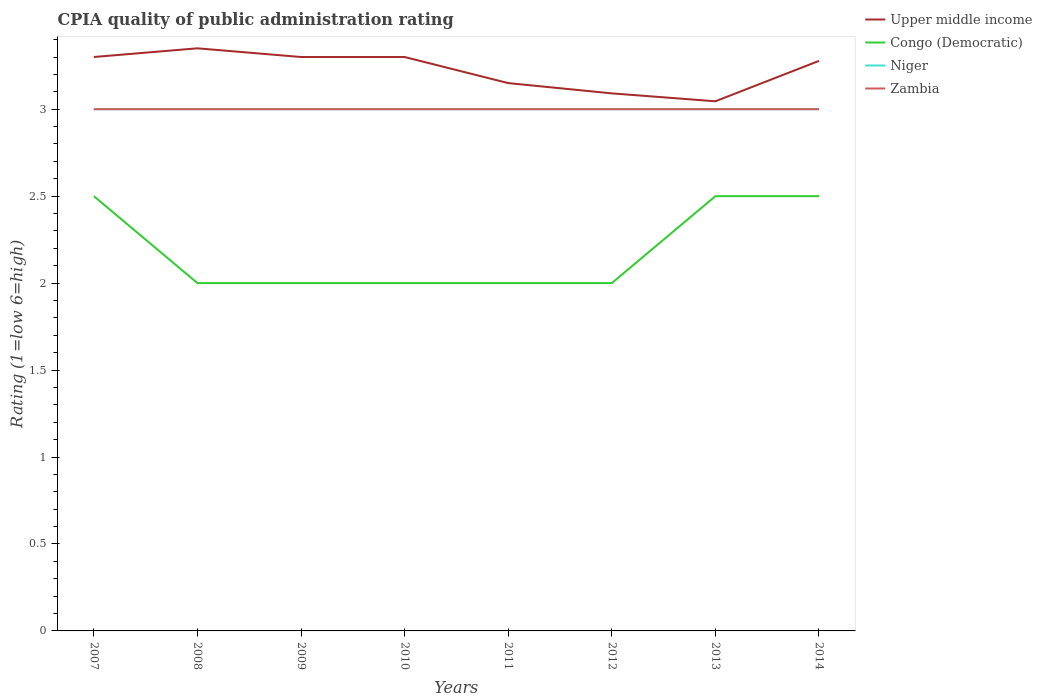How many different coloured lines are there?
Your answer should be very brief. 4. Across all years, what is the maximum CPIA rating in Zambia?
Your answer should be compact. 3. In which year was the CPIA rating in Upper middle income maximum?
Keep it short and to the point. 2013. What is the total CPIA rating in Niger in the graph?
Make the answer very short. 0. What is the difference between the highest and the second highest CPIA rating in Niger?
Ensure brevity in your answer.  0. What is the difference between the highest and the lowest CPIA rating in Congo (Democratic)?
Your answer should be compact. 3. How many years are there in the graph?
Your response must be concise. 8. What is the difference between two consecutive major ticks on the Y-axis?
Your answer should be very brief. 0.5. Does the graph contain any zero values?
Offer a terse response. No. Does the graph contain grids?
Offer a very short reply. No. Where does the legend appear in the graph?
Give a very brief answer. Top right. How are the legend labels stacked?
Give a very brief answer. Vertical. What is the title of the graph?
Your answer should be very brief. CPIA quality of public administration rating. Does "Madagascar" appear as one of the legend labels in the graph?
Your answer should be very brief. No. What is the label or title of the Y-axis?
Make the answer very short. Rating (1=low 6=high). What is the Rating (1=low 6=high) of Upper middle income in 2007?
Ensure brevity in your answer.  3.3. What is the Rating (1=low 6=high) in Upper middle income in 2008?
Offer a terse response. 3.35. What is the Rating (1=low 6=high) of Niger in 2009?
Make the answer very short. 3. What is the Rating (1=low 6=high) in Upper middle income in 2010?
Offer a very short reply. 3.3. What is the Rating (1=low 6=high) of Congo (Democratic) in 2010?
Provide a succinct answer. 2. What is the Rating (1=low 6=high) of Niger in 2010?
Keep it short and to the point. 3. What is the Rating (1=low 6=high) in Upper middle income in 2011?
Provide a short and direct response. 3.15. What is the Rating (1=low 6=high) in Niger in 2011?
Your answer should be compact. 3. What is the Rating (1=low 6=high) in Upper middle income in 2012?
Keep it short and to the point. 3.09. What is the Rating (1=low 6=high) of Congo (Democratic) in 2012?
Offer a very short reply. 2. What is the Rating (1=low 6=high) in Niger in 2012?
Your response must be concise. 3. What is the Rating (1=low 6=high) of Zambia in 2012?
Provide a short and direct response. 3. What is the Rating (1=low 6=high) of Upper middle income in 2013?
Your answer should be very brief. 3.05. What is the Rating (1=low 6=high) of Congo (Democratic) in 2013?
Ensure brevity in your answer.  2.5. What is the Rating (1=low 6=high) of Niger in 2013?
Give a very brief answer. 3. What is the Rating (1=low 6=high) in Zambia in 2013?
Make the answer very short. 3. What is the Rating (1=low 6=high) of Upper middle income in 2014?
Your answer should be compact. 3.28. What is the Rating (1=low 6=high) in Niger in 2014?
Offer a terse response. 3. What is the Rating (1=low 6=high) of Zambia in 2014?
Offer a terse response. 3. Across all years, what is the maximum Rating (1=low 6=high) in Upper middle income?
Provide a short and direct response. 3.35. Across all years, what is the maximum Rating (1=low 6=high) of Niger?
Provide a short and direct response. 3. Across all years, what is the minimum Rating (1=low 6=high) in Upper middle income?
Your answer should be very brief. 3.05. Across all years, what is the minimum Rating (1=low 6=high) in Niger?
Provide a succinct answer. 3. What is the total Rating (1=low 6=high) in Upper middle income in the graph?
Give a very brief answer. 25.81. What is the total Rating (1=low 6=high) in Niger in the graph?
Offer a terse response. 24. What is the total Rating (1=low 6=high) of Zambia in the graph?
Make the answer very short. 24. What is the difference between the Rating (1=low 6=high) of Upper middle income in 2007 and that in 2008?
Keep it short and to the point. -0.05. What is the difference between the Rating (1=low 6=high) in Zambia in 2007 and that in 2008?
Provide a short and direct response. 0. What is the difference between the Rating (1=low 6=high) of Upper middle income in 2007 and that in 2009?
Your response must be concise. 0. What is the difference between the Rating (1=low 6=high) of Congo (Democratic) in 2007 and that in 2009?
Give a very brief answer. 0.5. What is the difference between the Rating (1=low 6=high) in Upper middle income in 2007 and that in 2010?
Keep it short and to the point. 0. What is the difference between the Rating (1=low 6=high) in Congo (Democratic) in 2007 and that in 2011?
Ensure brevity in your answer.  0.5. What is the difference between the Rating (1=low 6=high) of Zambia in 2007 and that in 2011?
Keep it short and to the point. 0. What is the difference between the Rating (1=low 6=high) in Upper middle income in 2007 and that in 2012?
Provide a short and direct response. 0.21. What is the difference between the Rating (1=low 6=high) in Zambia in 2007 and that in 2012?
Offer a very short reply. 0. What is the difference between the Rating (1=low 6=high) of Upper middle income in 2007 and that in 2013?
Provide a succinct answer. 0.25. What is the difference between the Rating (1=low 6=high) in Congo (Democratic) in 2007 and that in 2013?
Keep it short and to the point. 0. What is the difference between the Rating (1=low 6=high) of Zambia in 2007 and that in 2013?
Your response must be concise. 0. What is the difference between the Rating (1=low 6=high) in Upper middle income in 2007 and that in 2014?
Make the answer very short. 0.02. What is the difference between the Rating (1=low 6=high) of Congo (Democratic) in 2007 and that in 2014?
Offer a very short reply. 0. What is the difference between the Rating (1=low 6=high) in Zambia in 2007 and that in 2014?
Ensure brevity in your answer.  0. What is the difference between the Rating (1=low 6=high) of Upper middle income in 2008 and that in 2009?
Keep it short and to the point. 0.05. What is the difference between the Rating (1=low 6=high) in Niger in 2008 and that in 2009?
Your response must be concise. 0. What is the difference between the Rating (1=low 6=high) of Zambia in 2008 and that in 2009?
Make the answer very short. 0. What is the difference between the Rating (1=low 6=high) in Upper middle income in 2008 and that in 2010?
Your answer should be very brief. 0.05. What is the difference between the Rating (1=low 6=high) of Niger in 2008 and that in 2010?
Provide a succinct answer. 0. What is the difference between the Rating (1=low 6=high) in Zambia in 2008 and that in 2010?
Ensure brevity in your answer.  0. What is the difference between the Rating (1=low 6=high) of Zambia in 2008 and that in 2011?
Provide a succinct answer. 0. What is the difference between the Rating (1=low 6=high) of Upper middle income in 2008 and that in 2012?
Offer a terse response. 0.26. What is the difference between the Rating (1=low 6=high) of Niger in 2008 and that in 2012?
Provide a succinct answer. 0. What is the difference between the Rating (1=low 6=high) in Upper middle income in 2008 and that in 2013?
Provide a succinct answer. 0.3. What is the difference between the Rating (1=low 6=high) in Congo (Democratic) in 2008 and that in 2013?
Your answer should be very brief. -0.5. What is the difference between the Rating (1=low 6=high) in Zambia in 2008 and that in 2013?
Your answer should be compact. 0. What is the difference between the Rating (1=low 6=high) of Upper middle income in 2008 and that in 2014?
Provide a short and direct response. 0.07. What is the difference between the Rating (1=low 6=high) of Niger in 2008 and that in 2014?
Ensure brevity in your answer.  0. What is the difference between the Rating (1=low 6=high) in Zambia in 2008 and that in 2014?
Provide a succinct answer. 0. What is the difference between the Rating (1=low 6=high) in Congo (Democratic) in 2009 and that in 2010?
Your answer should be very brief. 0. What is the difference between the Rating (1=low 6=high) in Upper middle income in 2009 and that in 2011?
Provide a short and direct response. 0.15. What is the difference between the Rating (1=low 6=high) in Congo (Democratic) in 2009 and that in 2011?
Ensure brevity in your answer.  0. What is the difference between the Rating (1=low 6=high) in Zambia in 2009 and that in 2011?
Your answer should be compact. 0. What is the difference between the Rating (1=low 6=high) of Upper middle income in 2009 and that in 2012?
Ensure brevity in your answer.  0.21. What is the difference between the Rating (1=low 6=high) of Upper middle income in 2009 and that in 2013?
Offer a very short reply. 0.25. What is the difference between the Rating (1=low 6=high) in Zambia in 2009 and that in 2013?
Provide a short and direct response. 0. What is the difference between the Rating (1=low 6=high) of Upper middle income in 2009 and that in 2014?
Your response must be concise. 0.02. What is the difference between the Rating (1=low 6=high) of Niger in 2009 and that in 2014?
Offer a terse response. 0. What is the difference between the Rating (1=low 6=high) of Zambia in 2009 and that in 2014?
Your answer should be compact. 0. What is the difference between the Rating (1=low 6=high) in Upper middle income in 2010 and that in 2011?
Give a very brief answer. 0.15. What is the difference between the Rating (1=low 6=high) in Congo (Democratic) in 2010 and that in 2011?
Offer a terse response. 0. What is the difference between the Rating (1=low 6=high) in Niger in 2010 and that in 2011?
Your response must be concise. 0. What is the difference between the Rating (1=low 6=high) of Upper middle income in 2010 and that in 2012?
Your answer should be compact. 0.21. What is the difference between the Rating (1=low 6=high) of Congo (Democratic) in 2010 and that in 2012?
Keep it short and to the point. 0. What is the difference between the Rating (1=low 6=high) in Zambia in 2010 and that in 2012?
Give a very brief answer. 0. What is the difference between the Rating (1=low 6=high) of Upper middle income in 2010 and that in 2013?
Give a very brief answer. 0.25. What is the difference between the Rating (1=low 6=high) of Niger in 2010 and that in 2013?
Provide a succinct answer. 0. What is the difference between the Rating (1=low 6=high) of Upper middle income in 2010 and that in 2014?
Your answer should be compact. 0.02. What is the difference between the Rating (1=low 6=high) in Congo (Democratic) in 2010 and that in 2014?
Your answer should be compact. -0.5. What is the difference between the Rating (1=low 6=high) in Upper middle income in 2011 and that in 2012?
Offer a very short reply. 0.06. What is the difference between the Rating (1=low 6=high) in Congo (Democratic) in 2011 and that in 2012?
Your answer should be compact. 0. What is the difference between the Rating (1=low 6=high) in Upper middle income in 2011 and that in 2013?
Your answer should be compact. 0.1. What is the difference between the Rating (1=low 6=high) in Congo (Democratic) in 2011 and that in 2013?
Offer a terse response. -0.5. What is the difference between the Rating (1=low 6=high) of Zambia in 2011 and that in 2013?
Your response must be concise. 0. What is the difference between the Rating (1=low 6=high) of Upper middle income in 2011 and that in 2014?
Give a very brief answer. -0.13. What is the difference between the Rating (1=low 6=high) of Niger in 2011 and that in 2014?
Provide a short and direct response. 0. What is the difference between the Rating (1=low 6=high) in Upper middle income in 2012 and that in 2013?
Offer a terse response. 0.05. What is the difference between the Rating (1=low 6=high) of Congo (Democratic) in 2012 and that in 2013?
Keep it short and to the point. -0.5. What is the difference between the Rating (1=low 6=high) in Niger in 2012 and that in 2013?
Your answer should be very brief. 0. What is the difference between the Rating (1=low 6=high) of Zambia in 2012 and that in 2013?
Your answer should be compact. 0. What is the difference between the Rating (1=low 6=high) of Upper middle income in 2012 and that in 2014?
Offer a very short reply. -0.19. What is the difference between the Rating (1=low 6=high) of Congo (Democratic) in 2012 and that in 2014?
Offer a very short reply. -0.5. What is the difference between the Rating (1=low 6=high) of Upper middle income in 2013 and that in 2014?
Provide a succinct answer. -0.23. What is the difference between the Rating (1=low 6=high) in Niger in 2013 and that in 2014?
Keep it short and to the point. 0. What is the difference between the Rating (1=low 6=high) in Zambia in 2013 and that in 2014?
Your answer should be very brief. 0. What is the difference between the Rating (1=low 6=high) of Upper middle income in 2007 and the Rating (1=low 6=high) of Niger in 2008?
Your answer should be very brief. 0.3. What is the difference between the Rating (1=low 6=high) in Upper middle income in 2007 and the Rating (1=low 6=high) in Zambia in 2008?
Your response must be concise. 0.3. What is the difference between the Rating (1=low 6=high) of Congo (Democratic) in 2007 and the Rating (1=low 6=high) of Niger in 2008?
Keep it short and to the point. -0.5. What is the difference between the Rating (1=low 6=high) of Upper middle income in 2007 and the Rating (1=low 6=high) of Congo (Democratic) in 2009?
Provide a short and direct response. 1.3. What is the difference between the Rating (1=low 6=high) in Upper middle income in 2007 and the Rating (1=low 6=high) in Zambia in 2009?
Your response must be concise. 0.3. What is the difference between the Rating (1=low 6=high) in Congo (Democratic) in 2007 and the Rating (1=low 6=high) in Niger in 2009?
Give a very brief answer. -0.5. What is the difference between the Rating (1=low 6=high) in Congo (Democratic) in 2007 and the Rating (1=low 6=high) in Zambia in 2009?
Your answer should be compact. -0.5. What is the difference between the Rating (1=low 6=high) in Upper middle income in 2007 and the Rating (1=low 6=high) in Congo (Democratic) in 2010?
Make the answer very short. 1.3. What is the difference between the Rating (1=low 6=high) in Upper middle income in 2007 and the Rating (1=low 6=high) in Zambia in 2011?
Your response must be concise. 0.3. What is the difference between the Rating (1=low 6=high) of Congo (Democratic) in 2007 and the Rating (1=low 6=high) of Niger in 2011?
Offer a very short reply. -0.5. What is the difference between the Rating (1=low 6=high) in Congo (Democratic) in 2007 and the Rating (1=low 6=high) in Zambia in 2011?
Keep it short and to the point. -0.5. What is the difference between the Rating (1=low 6=high) in Upper middle income in 2007 and the Rating (1=low 6=high) in Niger in 2012?
Your response must be concise. 0.3. What is the difference between the Rating (1=low 6=high) in Niger in 2007 and the Rating (1=low 6=high) in Zambia in 2012?
Ensure brevity in your answer.  0. What is the difference between the Rating (1=low 6=high) of Congo (Democratic) in 2007 and the Rating (1=low 6=high) of Zambia in 2013?
Keep it short and to the point. -0.5. What is the difference between the Rating (1=low 6=high) in Niger in 2007 and the Rating (1=low 6=high) in Zambia in 2013?
Give a very brief answer. 0. What is the difference between the Rating (1=low 6=high) in Upper middle income in 2007 and the Rating (1=low 6=high) in Congo (Democratic) in 2014?
Your answer should be very brief. 0.8. What is the difference between the Rating (1=low 6=high) in Upper middle income in 2007 and the Rating (1=low 6=high) in Zambia in 2014?
Give a very brief answer. 0.3. What is the difference between the Rating (1=low 6=high) in Congo (Democratic) in 2007 and the Rating (1=low 6=high) in Niger in 2014?
Keep it short and to the point. -0.5. What is the difference between the Rating (1=low 6=high) of Niger in 2007 and the Rating (1=low 6=high) of Zambia in 2014?
Provide a succinct answer. 0. What is the difference between the Rating (1=low 6=high) in Upper middle income in 2008 and the Rating (1=low 6=high) in Congo (Democratic) in 2009?
Keep it short and to the point. 1.35. What is the difference between the Rating (1=low 6=high) in Niger in 2008 and the Rating (1=low 6=high) in Zambia in 2009?
Give a very brief answer. 0. What is the difference between the Rating (1=low 6=high) in Upper middle income in 2008 and the Rating (1=low 6=high) in Congo (Democratic) in 2010?
Your answer should be compact. 1.35. What is the difference between the Rating (1=low 6=high) in Upper middle income in 2008 and the Rating (1=low 6=high) in Niger in 2010?
Give a very brief answer. 0.35. What is the difference between the Rating (1=low 6=high) in Upper middle income in 2008 and the Rating (1=low 6=high) in Zambia in 2010?
Keep it short and to the point. 0.35. What is the difference between the Rating (1=low 6=high) in Congo (Democratic) in 2008 and the Rating (1=low 6=high) in Zambia in 2010?
Offer a terse response. -1. What is the difference between the Rating (1=low 6=high) of Upper middle income in 2008 and the Rating (1=low 6=high) of Congo (Democratic) in 2011?
Offer a very short reply. 1.35. What is the difference between the Rating (1=low 6=high) of Upper middle income in 2008 and the Rating (1=low 6=high) of Niger in 2011?
Keep it short and to the point. 0.35. What is the difference between the Rating (1=low 6=high) of Upper middle income in 2008 and the Rating (1=low 6=high) of Zambia in 2011?
Your answer should be compact. 0.35. What is the difference between the Rating (1=low 6=high) of Upper middle income in 2008 and the Rating (1=low 6=high) of Congo (Democratic) in 2012?
Provide a succinct answer. 1.35. What is the difference between the Rating (1=low 6=high) of Upper middle income in 2008 and the Rating (1=low 6=high) of Niger in 2012?
Offer a terse response. 0.35. What is the difference between the Rating (1=low 6=high) of Upper middle income in 2008 and the Rating (1=low 6=high) of Zambia in 2012?
Give a very brief answer. 0.35. What is the difference between the Rating (1=low 6=high) in Congo (Democratic) in 2008 and the Rating (1=low 6=high) in Niger in 2012?
Your response must be concise. -1. What is the difference between the Rating (1=low 6=high) of Congo (Democratic) in 2008 and the Rating (1=low 6=high) of Zambia in 2012?
Ensure brevity in your answer.  -1. What is the difference between the Rating (1=low 6=high) of Upper middle income in 2008 and the Rating (1=low 6=high) of Niger in 2013?
Offer a very short reply. 0.35. What is the difference between the Rating (1=low 6=high) in Congo (Democratic) in 2008 and the Rating (1=low 6=high) in Niger in 2013?
Your response must be concise. -1. What is the difference between the Rating (1=low 6=high) in Congo (Democratic) in 2008 and the Rating (1=low 6=high) in Zambia in 2013?
Keep it short and to the point. -1. What is the difference between the Rating (1=low 6=high) of Upper middle income in 2008 and the Rating (1=low 6=high) of Congo (Democratic) in 2014?
Your answer should be compact. 0.85. What is the difference between the Rating (1=low 6=high) of Upper middle income in 2008 and the Rating (1=low 6=high) of Niger in 2014?
Keep it short and to the point. 0.35. What is the difference between the Rating (1=low 6=high) of Upper middle income in 2009 and the Rating (1=low 6=high) of Congo (Democratic) in 2010?
Offer a very short reply. 1.3. What is the difference between the Rating (1=low 6=high) of Congo (Democratic) in 2009 and the Rating (1=low 6=high) of Niger in 2010?
Make the answer very short. -1. What is the difference between the Rating (1=low 6=high) in Congo (Democratic) in 2009 and the Rating (1=low 6=high) in Zambia in 2010?
Provide a short and direct response. -1. What is the difference between the Rating (1=low 6=high) in Niger in 2009 and the Rating (1=low 6=high) in Zambia in 2010?
Ensure brevity in your answer.  0. What is the difference between the Rating (1=low 6=high) of Niger in 2009 and the Rating (1=low 6=high) of Zambia in 2011?
Make the answer very short. 0. What is the difference between the Rating (1=low 6=high) in Upper middle income in 2009 and the Rating (1=low 6=high) in Congo (Democratic) in 2012?
Your answer should be very brief. 1.3. What is the difference between the Rating (1=low 6=high) in Upper middle income in 2009 and the Rating (1=low 6=high) in Niger in 2012?
Your answer should be very brief. 0.3. What is the difference between the Rating (1=low 6=high) of Upper middle income in 2009 and the Rating (1=low 6=high) of Zambia in 2012?
Make the answer very short. 0.3. What is the difference between the Rating (1=low 6=high) of Congo (Democratic) in 2009 and the Rating (1=low 6=high) of Zambia in 2012?
Make the answer very short. -1. What is the difference between the Rating (1=low 6=high) in Niger in 2009 and the Rating (1=low 6=high) in Zambia in 2012?
Provide a short and direct response. 0. What is the difference between the Rating (1=low 6=high) of Upper middle income in 2009 and the Rating (1=low 6=high) of Zambia in 2013?
Your answer should be very brief. 0.3. What is the difference between the Rating (1=low 6=high) of Congo (Democratic) in 2009 and the Rating (1=low 6=high) of Niger in 2013?
Provide a succinct answer. -1. What is the difference between the Rating (1=low 6=high) of Congo (Democratic) in 2009 and the Rating (1=low 6=high) of Zambia in 2013?
Your answer should be very brief. -1. What is the difference between the Rating (1=low 6=high) in Niger in 2009 and the Rating (1=low 6=high) in Zambia in 2013?
Ensure brevity in your answer.  0. What is the difference between the Rating (1=low 6=high) in Upper middle income in 2009 and the Rating (1=low 6=high) in Congo (Democratic) in 2014?
Provide a succinct answer. 0.8. What is the difference between the Rating (1=low 6=high) in Upper middle income in 2009 and the Rating (1=low 6=high) in Niger in 2014?
Your answer should be compact. 0.3. What is the difference between the Rating (1=low 6=high) of Upper middle income in 2009 and the Rating (1=low 6=high) of Zambia in 2014?
Your response must be concise. 0.3. What is the difference between the Rating (1=low 6=high) in Niger in 2009 and the Rating (1=low 6=high) in Zambia in 2014?
Make the answer very short. 0. What is the difference between the Rating (1=low 6=high) in Upper middle income in 2010 and the Rating (1=low 6=high) in Congo (Democratic) in 2011?
Your response must be concise. 1.3. What is the difference between the Rating (1=low 6=high) of Upper middle income in 2010 and the Rating (1=low 6=high) of Niger in 2011?
Provide a short and direct response. 0.3. What is the difference between the Rating (1=low 6=high) of Upper middle income in 2010 and the Rating (1=low 6=high) of Zambia in 2011?
Keep it short and to the point. 0.3. What is the difference between the Rating (1=low 6=high) in Congo (Democratic) in 2010 and the Rating (1=low 6=high) in Zambia in 2011?
Ensure brevity in your answer.  -1. What is the difference between the Rating (1=low 6=high) of Niger in 2010 and the Rating (1=low 6=high) of Zambia in 2011?
Make the answer very short. 0. What is the difference between the Rating (1=low 6=high) of Upper middle income in 2010 and the Rating (1=low 6=high) of Congo (Democratic) in 2012?
Your answer should be very brief. 1.3. What is the difference between the Rating (1=low 6=high) of Upper middle income in 2010 and the Rating (1=low 6=high) of Niger in 2012?
Provide a short and direct response. 0.3. What is the difference between the Rating (1=low 6=high) in Upper middle income in 2010 and the Rating (1=low 6=high) in Zambia in 2012?
Your answer should be very brief. 0.3. What is the difference between the Rating (1=low 6=high) of Niger in 2010 and the Rating (1=low 6=high) of Zambia in 2012?
Make the answer very short. 0. What is the difference between the Rating (1=low 6=high) of Upper middle income in 2010 and the Rating (1=low 6=high) of Zambia in 2013?
Offer a terse response. 0.3. What is the difference between the Rating (1=low 6=high) in Congo (Democratic) in 2010 and the Rating (1=low 6=high) in Niger in 2013?
Your answer should be very brief. -1. What is the difference between the Rating (1=low 6=high) in Congo (Democratic) in 2010 and the Rating (1=low 6=high) in Zambia in 2013?
Keep it short and to the point. -1. What is the difference between the Rating (1=low 6=high) in Upper middle income in 2010 and the Rating (1=low 6=high) in Niger in 2014?
Keep it short and to the point. 0.3. What is the difference between the Rating (1=low 6=high) of Congo (Democratic) in 2010 and the Rating (1=low 6=high) of Zambia in 2014?
Keep it short and to the point. -1. What is the difference between the Rating (1=low 6=high) of Niger in 2010 and the Rating (1=low 6=high) of Zambia in 2014?
Keep it short and to the point. 0. What is the difference between the Rating (1=low 6=high) in Upper middle income in 2011 and the Rating (1=low 6=high) in Congo (Democratic) in 2012?
Keep it short and to the point. 1.15. What is the difference between the Rating (1=low 6=high) of Upper middle income in 2011 and the Rating (1=low 6=high) of Niger in 2012?
Make the answer very short. 0.15. What is the difference between the Rating (1=low 6=high) in Upper middle income in 2011 and the Rating (1=low 6=high) in Zambia in 2012?
Provide a succinct answer. 0.15. What is the difference between the Rating (1=low 6=high) in Congo (Democratic) in 2011 and the Rating (1=low 6=high) in Niger in 2012?
Ensure brevity in your answer.  -1. What is the difference between the Rating (1=low 6=high) in Upper middle income in 2011 and the Rating (1=low 6=high) in Congo (Democratic) in 2013?
Provide a succinct answer. 0.65. What is the difference between the Rating (1=low 6=high) of Upper middle income in 2011 and the Rating (1=low 6=high) of Niger in 2013?
Ensure brevity in your answer.  0.15. What is the difference between the Rating (1=low 6=high) of Congo (Democratic) in 2011 and the Rating (1=low 6=high) of Niger in 2013?
Your answer should be compact. -1. What is the difference between the Rating (1=low 6=high) of Niger in 2011 and the Rating (1=low 6=high) of Zambia in 2013?
Your answer should be very brief. 0. What is the difference between the Rating (1=low 6=high) in Upper middle income in 2011 and the Rating (1=low 6=high) in Congo (Democratic) in 2014?
Ensure brevity in your answer.  0.65. What is the difference between the Rating (1=low 6=high) of Upper middle income in 2011 and the Rating (1=low 6=high) of Niger in 2014?
Keep it short and to the point. 0.15. What is the difference between the Rating (1=low 6=high) of Upper middle income in 2011 and the Rating (1=low 6=high) of Zambia in 2014?
Offer a terse response. 0.15. What is the difference between the Rating (1=low 6=high) in Congo (Democratic) in 2011 and the Rating (1=low 6=high) in Zambia in 2014?
Your response must be concise. -1. What is the difference between the Rating (1=low 6=high) in Upper middle income in 2012 and the Rating (1=low 6=high) in Congo (Democratic) in 2013?
Your response must be concise. 0.59. What is the difference between the Rating (1=low 6=high) in Upper middle income in 2012 and the Rating (1=low 6=high) in Niger in 2013?
Make the answer very short. 0.09. What is the difference between the Rating (1=low 6=high) of Upper middle income in 2012 and the Rating (1=low 6=high) of Zambia in 2013?
Provide a short and direct response. 0.09. What is the difference between the Rating (1=low 6=high) in Congo (Democratic) in 2012 and the Rating (1=low 6=high) in Niger in 2013?
Provide a succinct answer. -1. What is the difference between the Rating (1=low 6=high) in Congo (Democratic) in 2012 and the Rating (1=low 6=high) in Zambia in 2013?
Give a very brief answer. -1. What is the difference between the Rating (1=low 6=high) in Niger in 2012 and the Rating (1=low 6=high) in Zambia in 2013?
Give a very brief answer. 0. What is the difference between the Rating (1=low 6=high) in Upper middle income in 2012 and the Rating (1=low 6=high) in Congo (Democratic) in 2014?
Give a very brief answer. 0.59. What is the difference between the Rating (1=low 6=high) of Upper middle income in 2012 and the Rating (1=low 6=high) of Niger in 2014?
Ensure brevity in your answer.  0.09. What is the difference between the Rating (1=low 6=high) of Upper middle income in 2012 and the Rating (1=low 6=high) of Zambia in 2014?
Offer a terse response. 0.09. What is the difference between the Rating (1=low 6=high) of Congo (Democratic) in 2012 and the Rating (1=low 6=high) of Niger in 2014?
Provide a succinct answer. -1. What is the difference between the Rating (1=low 6=high) of Congo (Democratic) in 2012 and the Rating (1=low 6=high) of Zambia in 2014?
Your response must be concise. -1. What is the difference between the Rating (1=low 6=high) of Upper middle income in 2013 and the Rating (1=low 6=high) of Congo (Democratic) in 2014?
Provide a short and direct response. 0.55. What is the difference between the Rating (1=low 6=high) in Upper middle income in 2013 and the Rating (1=low 6=high) in Niger in 2014?
Offer a very short reply. 0.05. What is the difference between the Rating (1=low 6=high) in Upper middle income in 2013 and the Rating (1=low 6=high) in Zambia in 2014?
Your response must be concise. 0.05. What is the difference between the Rating (1=low 6=high) in Congo (Democratic) in 2013 and the Rating (1=low 6=high) in Niger in 2014?
Offer a very short reply. -0.5. What is the difference between the Rating (1=low 6=high) of Niger in 2013 and the Rating (1=low 6=high) of Zambia in 2014?
Make the answer very short. 0. What is the average Rating (1=low 6=high) in Upper middle income per year?
Make the answer very short. 3.23. What is the average Rating (1=low 6=high) in Congo (Democratic) per year?
Your answer should be very brief. 2.19. What is the average Rating (1=low 6=high) of Niger per year?
Your response must be concise. 3. What is the average Rating (1=low 6=high) of Zambia per year?
Offer a very short reply. 3. In the year 2007, what is the difference between the Rating (1=low 6=high) in Upper middle income and Rating (1=low 6=high) in Congo (Democratic)?
Your response must be concise. 0.8. In the year 2007, what is the difference between the Rating (1=low 6=high) of Upper middle income and Rating (1=low 6=high) of Niger?
Provide a short and direct response. 0.3. In the year 2007, what is the difference between the Rating (1=low 6=high) of Upper middle income and Rating (1=low 6=high) of Zambia?
Your answer should be very brief. 0.3. In the year 2007, what is the difference between the Rating (1=low 6=high) in Niger and Rating (1=low 6=high) in Zambia?
Offer a very short reply. 0. In the year 2008, what is the difference between the Rating (1=low 6=high) in Upper middle income and Rating (1=low 6=high) in Congo (Democratic)?
Your answer should be very brief. 1.35. In the year 2008, what is the difference between the Rating (1=low 6=high) in Congo (Democratic) and Rating (1=low 6=high) in Zambia?
Give a very brief answer. -1. In the year 2009, what is the difference between the Rating (1=low 6=high) in Upper middle income and Rating (1=low 6=high) in Niger?
Your answer should be very brief. 0.3. In the year 2009, what is the difference between the Rating (1=low 6=high) in Congo (Democratic) and Rating (1=low 6=high) in Niger?
Offer a very short reply. -1. In the year 2009, what is the difference between the Rating (1=low 6=high) in Congo (Democratic) and Rating (1=low 6=high) in Zambia?
Provide a succinct answer. -1. In the year 2010, what is the difference between the Rating (1=low 6=high) in Upper middle income and Rating (1=low 6=high) in Congo (Democratic)?
Keep it short and to the point. 1.3. In the year 2010, what is the difference between the Rating (1=low 6=high) in Upper middle income and Rating (1=low 6=high) in Zambia?
Your answer should be compact. 0.3. In the year 2010, what is the difference between the Rating (1=low 6=high) of Congo (Democratic) and Rating (1=low 6=high) of Niger?
Your answer should be compact. -1. In the year 2010, what is the difference between the Rating (1=low 6=high) of Congo (Democratic) and Rating (1=low 6=high) of Zambia?
Make the answer very short. -1. In the year 2010, what is the difference between the Rating (1=low 6=high) of Niger and Rating (1=low 6=high) of Zambia?
Provide a succinct answer. 0. In the year 2011, what is the difference between the Rating (1=low 6=high) of Upper middle income and Rating (1=low 6=high) of Congo (Democratic)?
Provide a short and direct response. 1.15. In the year 2011, what is the difference between the Rating (1=low 6=high) in Congo (Democratic) and Rating (1=low 6=high) in Zambia?
Make the answer very short. -1. In the year 2012, what is the difference between the Rating (1=low 6=high) in Upper middle income and Rating (1=low 6=high) in Congo (Democratic)?
Offer a very short reply. 1.09. In the year 2012, what is the difference between the Rating (1=low 6=high) in Upper middle income and Rating (1=low 6=high) in Niger?
Keep it short and to the point. 0.09. In the year 2012, what is the difference between the Rating (1=low 6=high) in Upper middle income and Rating (1=low 6=high) in Zambia?
Provide a short and direct response. 0.09. In the year 2012, what is the difference between the Rating (1=low 6=high) in Congo (Democratic) and Rating (1=low 6=high) in Zambia?
Your response must be concise. -1. In the year 2013, what is the difference between the Rating (1=low 6=high) of Upper middle income and Rating (1=low 6=high) of Congo (Democratic)?
Your response must be concise. 0.55. In the year 2013, what is the difference between the Rating (1=low 6=high) of Upper middle income and Rating (1=low 6=high) of Niger?
Your answer should be very brief. 0.05. In the year 2013, what is the difference between the Rating (1=low 6=high) in Upper middle income and Rating (1=low 6=high) in Zambia?
Your answer should be very brief. 0.05. In the year 2013, what is the difference between the Rating (1=low 6=high) in Congo (Democratic) and Rating (1=low 6=high) in Niger?
Your answer should be very brief. -0.5. In the year 2013, what is the difference between the Rating (1=low 6=high) in Congo (Democratic) and Rating (1=low 6=high) in Zambia?
Provide a succinct answer. -0.5. In the year 2013, what is the difference between the Rating (1=low 6=high) of Niger and Rating (1=low 6=high) of Zambia?
Keep it short and to the point. 0. In the year 2014, what is the difference between the Rating (1=low 6=high) in Upper middle income and Rating (1=low 6=high) in Congo (Democratic)?
Give a very brief answer. 0.78. In the year 2014, what is the difference between the Rating (1=low 6=high) in Upper middle income and Rating (1=low 6=high) in Niger?
Your response must be concise. 0.28. In the year 2014, what is the difference between the Rating (1=low 6=high) of Upper middle income and Rating (1=low 6=high) of Zambia?
Offer a very short reply. 0.28. In the year 2014, what is the difference between the Rating (1=low 6=high) in Congo (Democratic) and Rating (1=low 6=high) in Niger?
Your response must be concise. -0.5. In the year 2014, what is the difference between the Rating (1=low 6=high) of Congo (Democratic) and Rating (1=low 6=high) of Zambia?
Offer a very short reply. -0.5. In the year 2014, what is the difference between the Rating (1=low 6=high) of Niger and Rating (1=low 6=high) of Zambia?
Your answer should be very brief. 0. What is the ratio of the Rating (1=low 6=high) in Upper middle income in 2007 to that in 2008?
Offer a terse response. 0.99. What is the ratio of the Rating (1=low 6=high) in Congo (Democratic) in 2007 to that in 2008?
Offer a very short reply. 1.25. What is the ratio of the Rating (1=low 6=high) in Zambia in 2007 to that in 2008?
Offer a very short reply. 1. What is the ratio of the Rating (1=low 6=high) in Zambia in 2007 to that in 2009?
Your answer should be compact. 1. What is the ratio of the Rating (1=low 6=high) of Congo (Democratic) in 2007 to that in 2010?
Give a very brief answer. 1.25. What is the ratio of the Rating (1=low 6=high) in Upper middle income in 2007 to that in 2011?
Provide a short and direct response. 1.05. What is the ratio of the Rating (1=low 6=high) of Congo (Democratic) in 2007 to that in 2011?
Your answer should be compact. 1.25. What is the ratio of the Rating (1=low 6=high) in Niger in 2007 to that in 2011?
Make the answer very short. 1. What is the ratio of the Rating (1=low 6=high) of Zambia in 2007 to that in 2011?
Offer a terse response. 1. What is the ratio of the Rating (1=low 6=high) in Upper middle income in 2007 to that in 2012?
Ensure brevity in your answer.  1.07. What is the ratio of the Rating (1=low 6=high) in Congo (Democratic) in 2007 to that in 2012?
Your answer should be very brief. 1.25. What is the ratio of the Rating (1=low 6=high) in Zambia in 2007 to that in 2012?
Give a very brief answer. 1. What is the ratio of the Rating (1=low 6=high) in Upper middle income in 2007 to that in 2013?
Provide a succinct answer. 1.08. What is the ratio of the Rating (1=low 6=high) of Congo (Democratic) in 2007 to that in 2013?
Offer a very short reply. 1. What is the ratio of the Rating (1=low 6=high) of Niger in 2007 to that in 2013?
Offer a terse response. 1. What is the ratio of the Rating (1=low 6=high) in Zambia in 2007 to that in 2013?
Provide a succinct answer. 1. What is the ratio of the Rating (1=low 6=high) of Upper middle income in 2007 to that in 2014?
Keep it short and to the point. 1.01. What is the ratio of the Rating (1=low 6=high) of Niger in 2007 to that in 2014?
Provide a succinct answer. 1. What is the ratio of the Rating (1=low 6=high) in Upper middle income in 2008 to that in 2009?
Keep it short and to the point. 1.02. What is the ratio of the Rating (1=low 6=high) in Congo (Democratic) in 2008 to that in 2009?
Provide a short and direct response. 1. What is the ratio of the Rating (1=low 6=high) in Upper middle income in 2008 to that in 2010?
Keep it short and to the point. 1.02. What is the ratio of the Rating (1=low 6=high) of Congo (Democratic) in 2008 to that in 2010?
Keep it short and to the point. 1. What is the ratio of the Rating (1=low 6=high) in Upper middle income in 2008 to that in 2011?
Give a very brief answer. 1.06. What is the ratio of the Rating (1=low 6=high) in Niger in 2008 to that in 2011?
Give a very brief answer. 1. What is the ratio of the Rating (1=low 6=high) in Zambia in 2008 to that in 2011?
Offer a terse response. 1. What is the ratio of the Rating (1=low 6=high) in Upper middle income in 2008 to that in 2012?
Keep it short and to the point. 1.08. What is the ratio of the Rating (1=low 6=high) in Congo (Democratic) in 2008 to that in 2012?
Provide a short and direct response. 1. What is the ratio of the Rating (1=low 6=high) in Upper middle income in 2008 to that in 2013?
Keep it short and to the point. 1.1. What is the ratio of the Rating (1=low 6=high) of Congo (Democratic) in 2008 to that in 2013?
Provide a succinct answer. 0.8. What is the ratio of the Rating (1=low 6=high) of Niger in 2008 to that in 2013?
Your answer should be compact. 1. What is the ratio of the Rating (1=low 6=high) of Congo (Democratic) in 2008 to that in 2014?
Ensure brevity in your answer.  0.8. What is the ratio of the Rating (1=low 6=high) of Zambia in 2008 to that in 2014?
Provide a short and direct response. 1. What is the ratio of the Rating (1=low 6=high) in Upper middle income in 2009 to that in 2010?
Your response must be concise. 1. What is the ratio of the Rating (1=low 6=high) in Niger in 2009 to that in 2010?
Your answer should be compact. 1. What is the ratio of the Rating (1=low 6=high) of Zambia in 2009 to that in 2010?
Give a very brief answer. 1. What is the ratio of the Rating (1=low 6=high) of Upper middle income in 2009 to that in 2011?
Your response must be concise. 1.05. What is the ratio of the Rating (1=low 6=high) of Congo (Democratic) in 2009 to that in 2011?
Provide a succinct answer. 1. What is the ratio of the Rating (1=low 6=high) in Zambia in 2009 to that in 2011?
Your response must be concise. 1. What is the ratio of the Rating (1=low 6=high) of Upper middle income in 2009 to that in 2012?
Keep it short and to the point. 1.07. What is the ratio of the Rating (1=low 6=high) in Niger in 2009 to that in 2012?
Provide a short and direct response. 1. What is the ratio of the Rating (1=low 6=high) in Zambia in 2009 to that in 2012?
Give a very brief answer. 1. What is the ratio of the Rating (1=low 6=high) in Upper middle income in 2009 to that in 2013?
Provide a short and direct response. 1.08. What is the ratio of the Rating (1=low 6=high) of Congo (Democratic) in 2009 to that in 2013?
Your response must be concise. 0.8. What is the ratio of the Rating (1=low 6=high) in Upper middle income in 2009 to that in 2014?
Your response must be concise. 1.01. What is the ratio of the Rating (1=low 6=high) in Congo (Democratic) in 2009 to that in 2014?
Make the answer very short. 0.8. What is the ratio of the Rating (1=low 6=high) in Upper middle income in 2010 to that in 2011?
Offer a terse response. 1.05. What is the ratio of the Rating (1=low 6=high) in Zambia in 2010 to that in 2011?
Keep it short and to the point. 1. What is the ratio of the Rating (1=low 6=high) of Upper middle income in 2010 to that in 2012?
Provide a succinct answer. 1.07. What is the ratio of the Rating (1=low 6=high) in Niger in 2010 to that in 2012?
Provide a succinct answer. 1. What is the ratio of the Rating (1=low 6=high) in Zambia in 2010 to that in 2012?
Give a very brief answer. 1. What is the ratio of the Rating (1=low 6=high) of Upper middle income in 2010 to that in 2013?
Keep it short and to the point. 1.08. What is the ratio of the Rating (1=low 6=high) of Niger in 2010 to that in 2013?
Provide a succinct answer. 1. What is the ratio of the Rating (1=low 6=high) in Zambia in 2010 to that in 2013?
Your answer should be compact. 1. What is the ratio of the Rating (1=low 6=high) of Upper middle income in 2010 to that in 2014?
Provide a succinct answer. 1.01. What is the ratio of the Rating (1=low 6=high) in Niger in 2010 to that in 2014?
Ensure brevity in your answer.  1. What is the ratio of the Rating (1=low 6=high) of Upper middle income in 2011 to that in 2012?
Make the answer very short. 1.02. What is the ratio of the Rating (1=low 6=high) in Zambia in 2011 to that in 2012?
Give a very brief answer. 1. What is the ratio of the Rating (1=low 6=high) of Upper middle income in 2011 to that in 2013?
Make the answer very short. 1.03. What is the ratio of the Rating (1=low 6=high) of Niger in 2011 to that in 2013?
Make the answer very short. 1. What is the ratio of the Rating (1=low 6=high) of Upper middle income in 2011 to that in 2014?
Provide a short and direct response. 0.96. What is the ratio of the Rating (1=low 6=high) in Congo (Democratic) in 2011 to that in 2014?
Provide a succinct answer. 0.8. What is the ratio of the Rating (1=low 6=high) of Upper middle income in 2012 to that in 2013?
Keep it short and to the point. 1.01. What is the ratio of the Rating (1=low 6=high) of Upper middle income in 2012 to that in 2014?
Make the answer very short. 0.94. What is the ratio of the Rating (1=low 6=high) of Congo (Democratic) in 2012 to that in 2014?
Keep it short and to the point. 0.8. What is the ratio of the Rating (1=low 6=high) in Zambia in 2012 to that in 2014?
Provide a short and direct response. 1. What is the ratio of the Rating (1=low 6=high) in Upper middle income in 2013 to that in 2014?
Provide a short and direct response. 0.93. What is the ratio of the Rating (1=low 6=high) of Congo (Democratic) in 2013 to that in 2014?
Your answer should be very brief. 1. What is the ratio of the Rating (1=low 6=high) in Niger in 2013 to that in 2014?
Your answer should be compact. 1. What is the ratio of the Rating (1=low 6=high) in Zambia in 2013 to that in 2014?
Provide a succinct answer. 1. What is the difference between the highest and the second highest Rating (1=low 6=high) of Congo (Democratic)?
Give a very brief answer. 0. What is the difference between the highest and the lowest Rating (1=low 6=high) in Upper middle income?
Your answer should be compact. 0.3. What is the difference between the highest and the lowest Rating (1=low 6=high) in Congo (Democratic)?
Your answer should be very brief. 0.5. What is the difference between the highest and the lowest Rating (1=low 6=high) of Niger?
Offer a terse response. 0. 